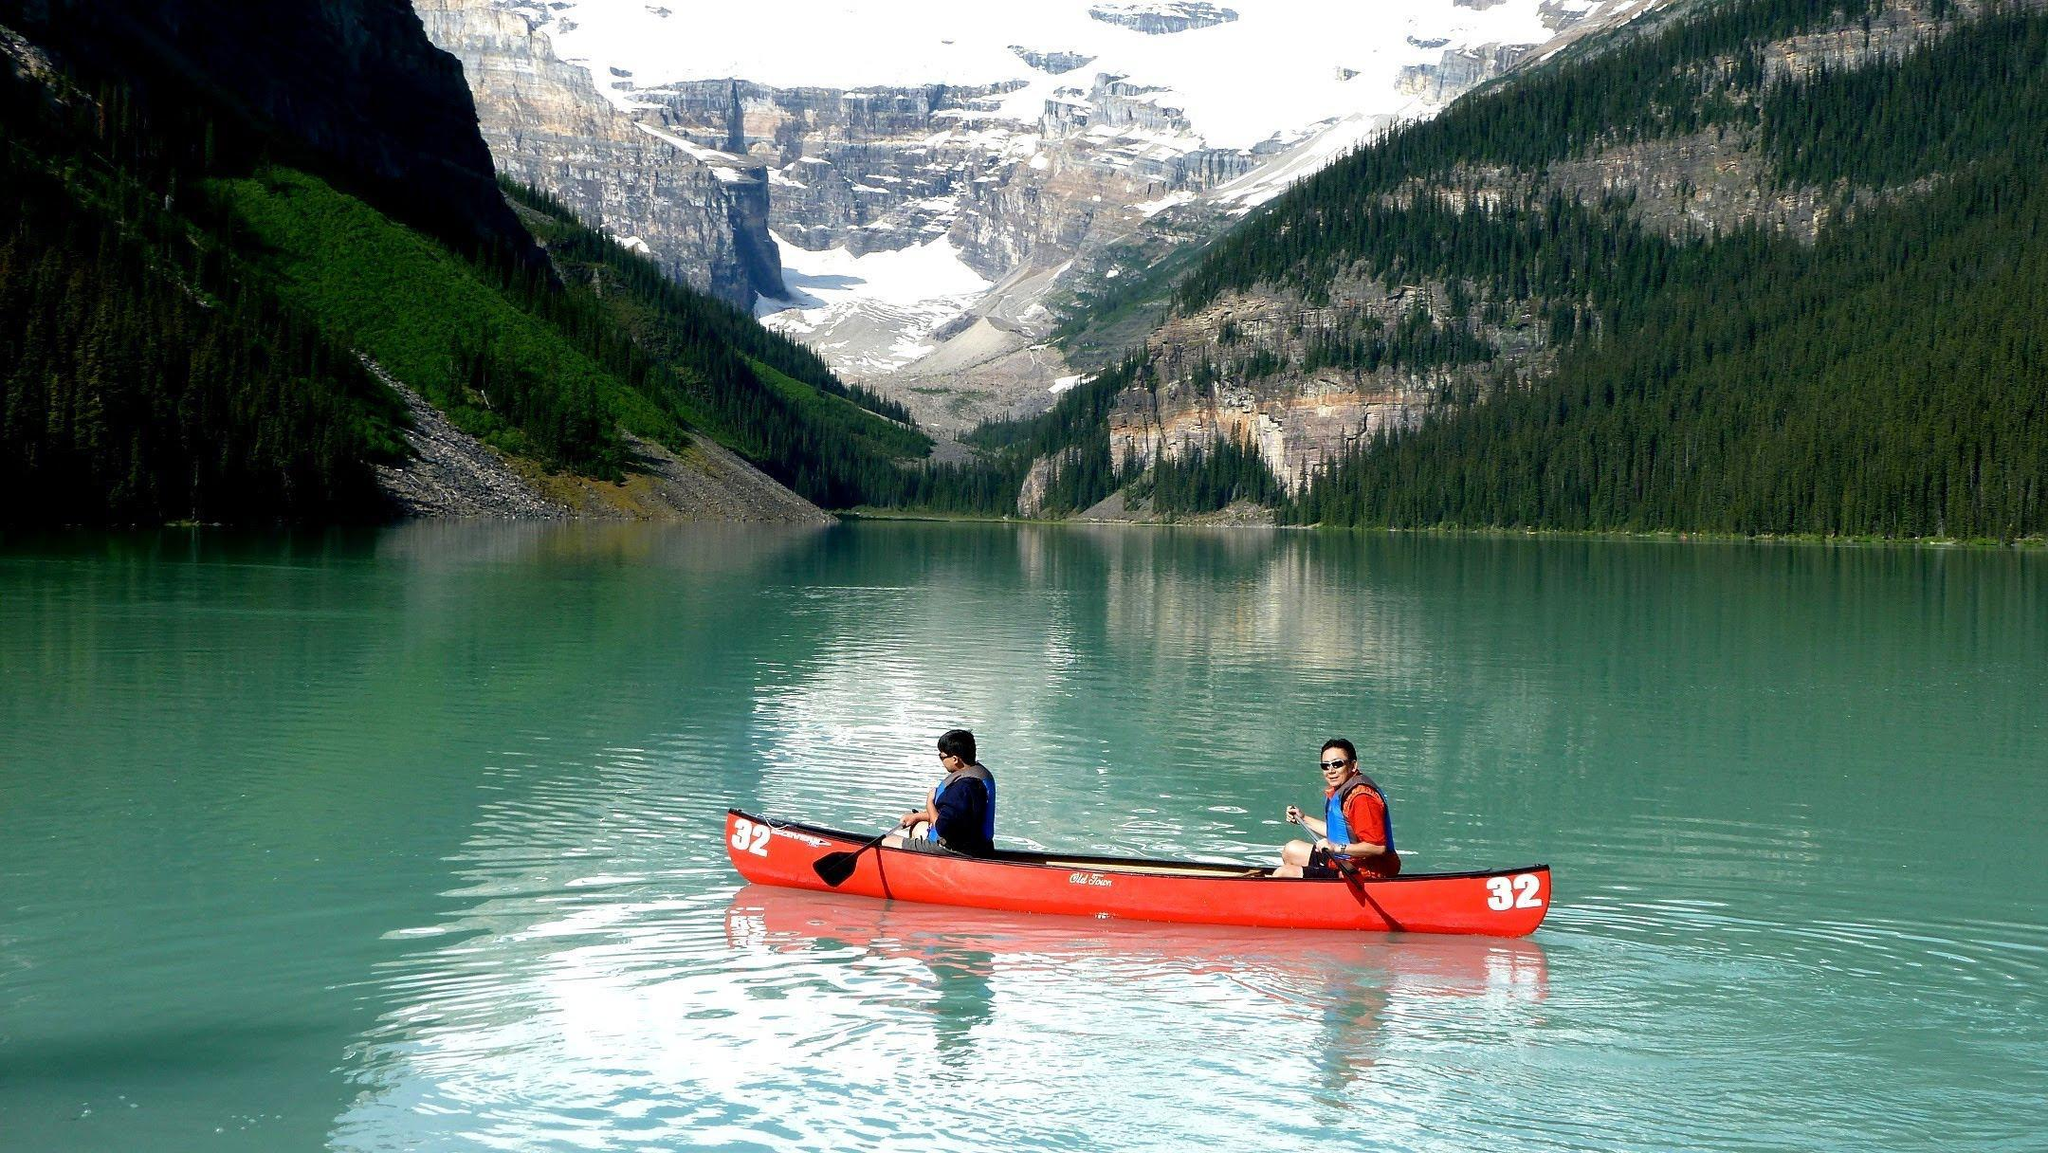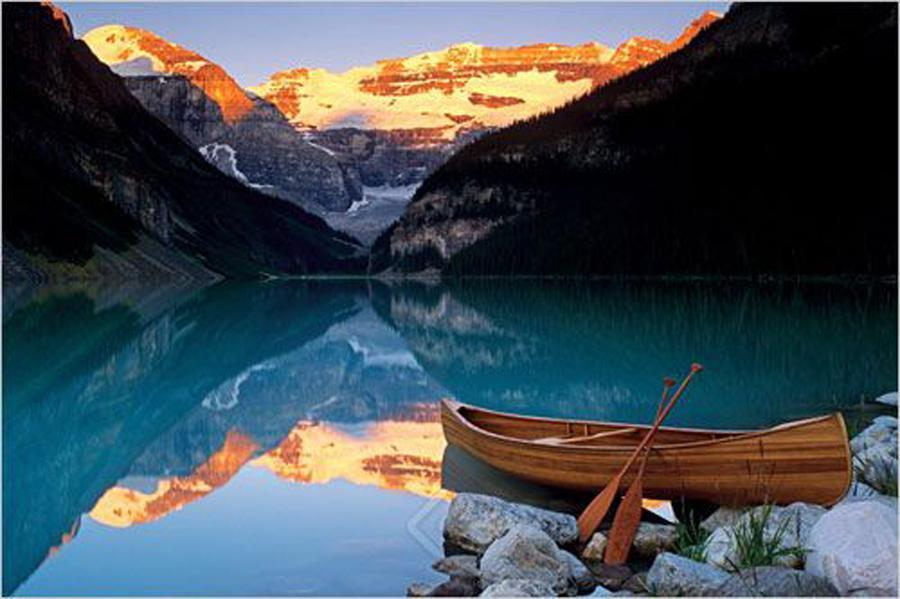The first image is the image on the left, the second image is the image on the right. Given the left and right images, does the statement "In one image there is a red boat with two people and the other image is a empty boat floating on the water." hold true? Answer yes or no. Yes. The first image is the image on the left, the second image is the image on the right. Considering the images on both sides, is "There is only one red canoe." valid? Answer yes or no. Yes. 